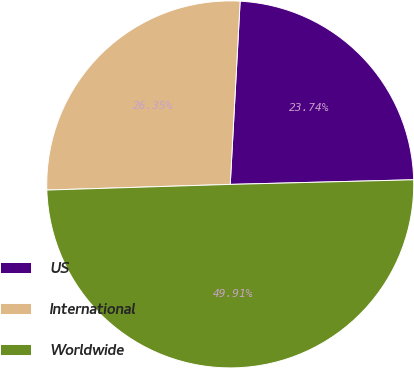Convert chart to OTSL. <chart><loc_0><loc_0><loc_500><loc_500><pie_chart><fcel>US<fcel>International<fcel>Worldwide<nl><fcel>23.74%<fcel>26.35%<fcel>49.91%<nl></chart> 